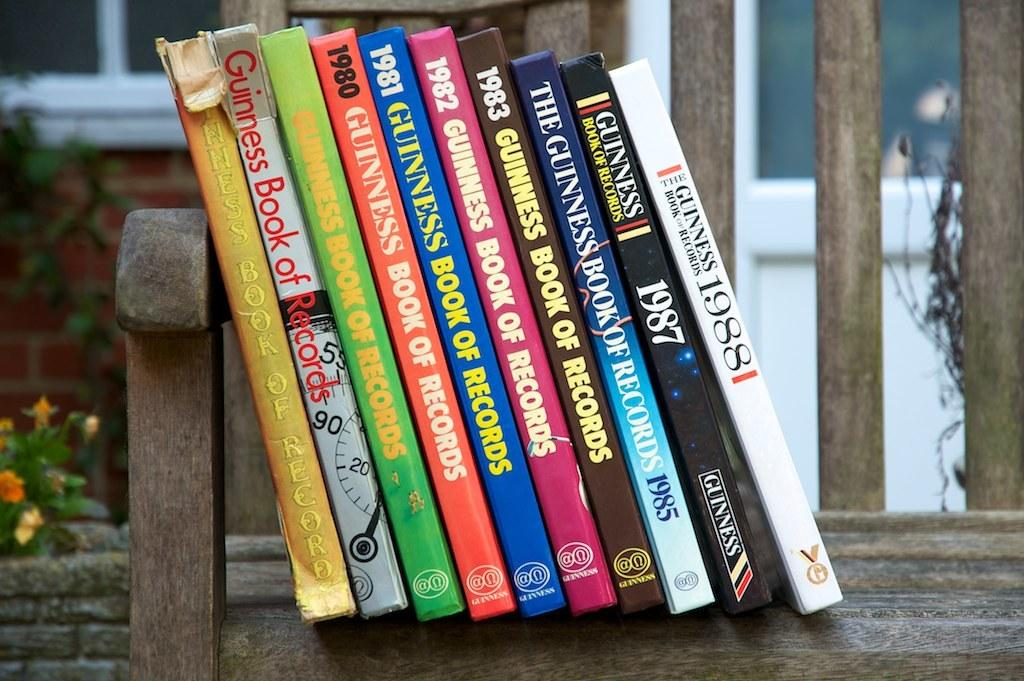<image>
Write a terse but informative summary of the picture. A collection of Guinness Book of Records books from the 1980's. 